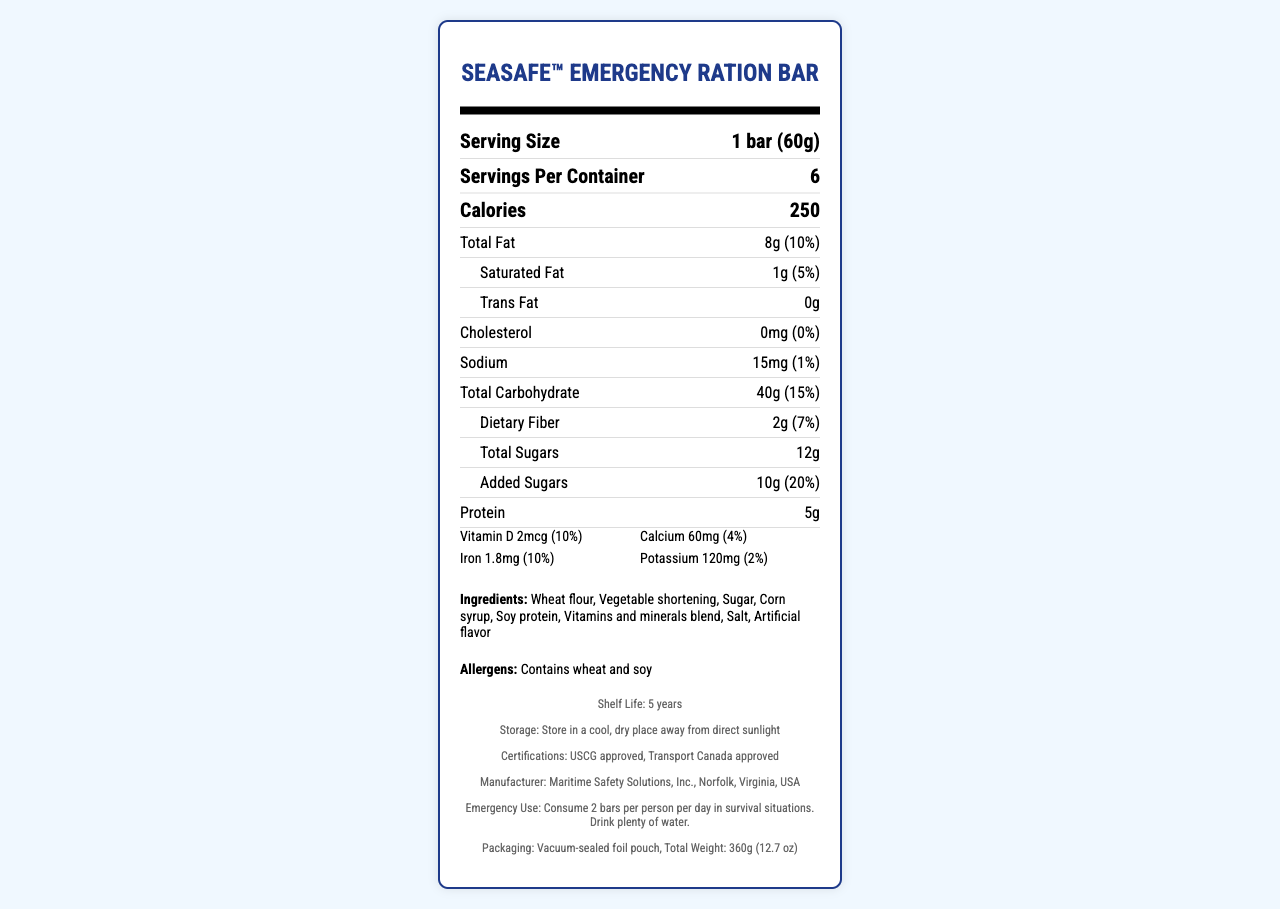what is the serving size of the SeaSafe™ Emergency Ration Bar? The document specifies the serving size as "1 bar (60g)" under the "Serving Size" section.
Answer: 1 bar (60g) how many calories are in one serving of the SeaSafe™ Emergency Ration Bar? The document states that there are 250 calories per serving in the "Calories" section.
Answer: 250 how many servings are there per container? The document mentions that there are 6 servings per container under the "Servings Per Container" section.
Answer: 6 what is the total fat content per serving? The document lists the total fat content per serving as "8g" which equals "10%" of the daily value under the "Total Fat" section.
Answer: 8g (10%) how many grams of protein does one serving contain? The document specifies that there are 5 grams of protein per serving under the "Protein" section.
Answer: 5g which of the following vitamins and minerals are listed with their daily values? A. Vitamin C B. Calcium C. Potassium D. Vitamin D The vitamins and minerals listed with their daily values are Vitamin D, Calcium, Iron, and Potassium. Vitamin C is not listed.
Answer: D What is the daily value percentage for added sugars? A. 5% B. 10% C. 20% D. 25% The document states that the daily value percentage for added sugars is "20%" in the "Added Sugars" section.
Answer: C does the SeaSafe™ Emergency Ration Bar contain any cholesterol? The document states that the amount of cholesterol is "0mg" which is "0%" of the daily value under the "Cholesterol" section.
Answer: No What is the main idea of the document? The document is a comprehensive nutritional facts label for the SeaSafe™ Emergency Ration Bar, listing all relevant details about the product's nutritional values, ingredients, and usage.
Answer: The document provides detailed nutritional information about the SeaSafe™ Emergency Ration Bar, including serving size, macronutrient content, vitamins and minerals, ingredients, allergens, shelf life, storage instructions, certifications, manufacturer details, and emergency use instructions. what is the sodium content in one serving of the ration bar? The document specifies the sodium content per serving as "15mg," which is "1%" of the daily value under the "Sodium" section.
Answer: 15mg (1%) what is the total carbohydrate content including dietary fiber and sugars? The document lists the total carbohydrate content as "40g" which equals "15%" of the daily value under the "Total Carbohydrate" section.
Answer: 40g (15%) what are the main allergens in this emergency ration bar? The document states the allergens as "Contains wheat and soy" under the "Allergens" section.
Answer: Wheat and soy does this emergency ration bar contain artificial flavors? The document lists "Artificial flavor" in the ingredients section, indicating it contains artificial flavors.
Answer: Yes who is the manufacturer of the SeaSafe™ Emergency Ration Bar? The document provides the manufacturer information under the "Manufacturer" section, stating "Maritime Safety Solutions, Inc."
Answer: Maritime Safety Solutions, Inc. how much dietary fiber does one serving of the ration bar contain? The document specifies that there are "2g" of dietary fiber, which is "7%" of the daily value under the "Dietary Fiber" section.
Answer: 2g (7%) what is the shelf life of the SeaSafe™ Emergency Ration Bar? The document mentions the shelf life as "5 years" under the "Shelf Life" section.
Answer: 5 years what are the storage instructions for this emergency ration? The document specifies the storage instructions as "Store in a cool, dry place away from direct sunlight" under the "Storage" section.
Answer: Store in a cool, dry place away from direct sunlight how many grams of saturated fat does one serving of the ration bar contain? The document lists the saturated fat amount as "1g," which is "5%" of the daily value under the "Saturated Fat" section.
Answer: 1g (5%) what is the amount of iron in one serving? The document states that the amount of iron per serving is "1.8mg," which is "10%" of the daily value under the "Iron" section.
Answer: 1.8mg (10%) What is the potassium content per serving? The document specifies that there is "120mg" of potassium per serving, which is "2%" of the daily value under the "Potassium" section.
Answer: 120mg (2%) what certifications does the product have? The document lists the certifications under the "Certifications" section, specifying "USCG approved" and "Transport Canada approved."
Answer: USCG approved and Transport Canada approved What is the contact number for the manufacturer? The document lists the contact number for Maritime Safety Solutions, Inc. under the "Manufacturer" section as "+1 (757) 555-1234."
Answer: +1 (757) 555-1234 Is this emergency ration suitable for someone with a gluten allergy? The document lists "Wheat flour" as one of the ingredients and specifies that it contains wheat, making it unsuitable for someone with a gluten allergy.
Answer: No 